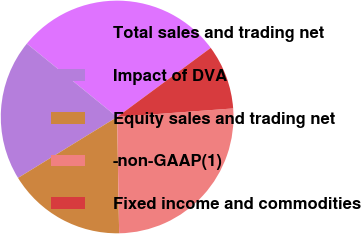<chart> <loc_0><loc_0><loc_500><loc_500><pie_chart><fcel>Total sales and trading net<fcel>Impact of DVA<fcel>Equity sales and trading net<fcel>-non-GAAP(1)<fcel>Fixed income and commodities<nl><fcel>29.03%<fcel>19.63%<fcel>16.5%<fcel>25.9%<fcel>8.95%<nl></chart> 